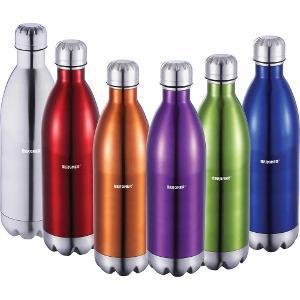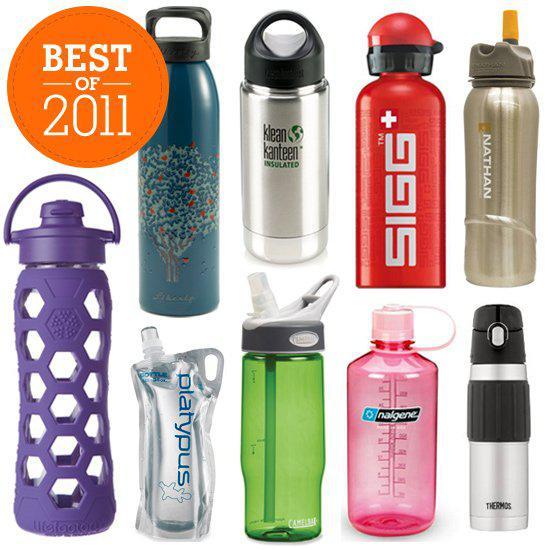The first image is the image on the left, the second image is the image on the right. For the images shown, is this caption "There are fifteen bottles in total." true? Answer yes or no. Yes. The first image is the image on the left, the second image is the image on the right. Evaluate the accuracy of this statement regarding the images: "The left and right image contains the same number of rows of stainless steel water bottles.". Is it true? Answer yes or no. No. 